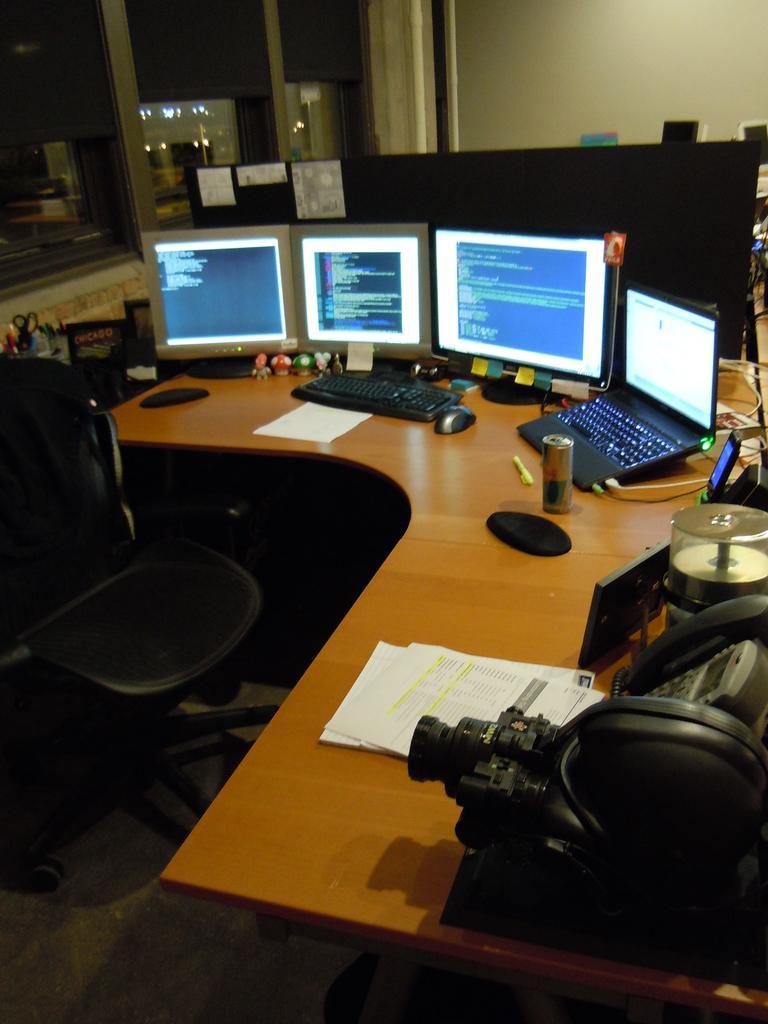Can you describe this image briefly? In this picture for there are three monitors and a laptop, keyboard and mouse, there some papers and there is a telephone, camera and there is a pen stand with some pens in a and their wall in this window onto the left side 